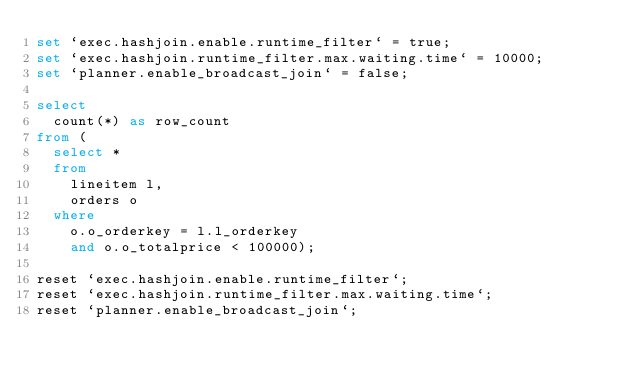<code> <loc_0><loc_0><loc_500><loc_500><_SQL_>set `exec.hashjoin.enable.runtime_filter` = true;
set `exec.hashjoin.runtime_filter.max.waiting.time` = 10000;
set `planner.enable_broadcast_join` = false;

select
  count(*) as row_count
from (
  select *
  from
    lineitem l,
    orders o
  where
    o.o_orderkey = l.l_orderkey
    and o.o_totalprice < 100000);

reset `exec.hashjoin.enable.runtime_filter`;
reset `exec.hashjoin.runtime_filter.max.waiting.time`;
reset `planner.enable_broadcast_join`;</code> 